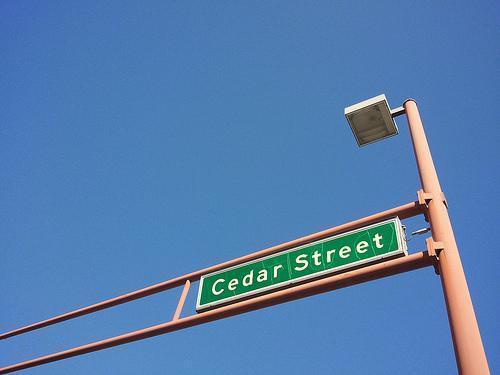How many street signs are pictured here?
Give a very brief answer. 1. 